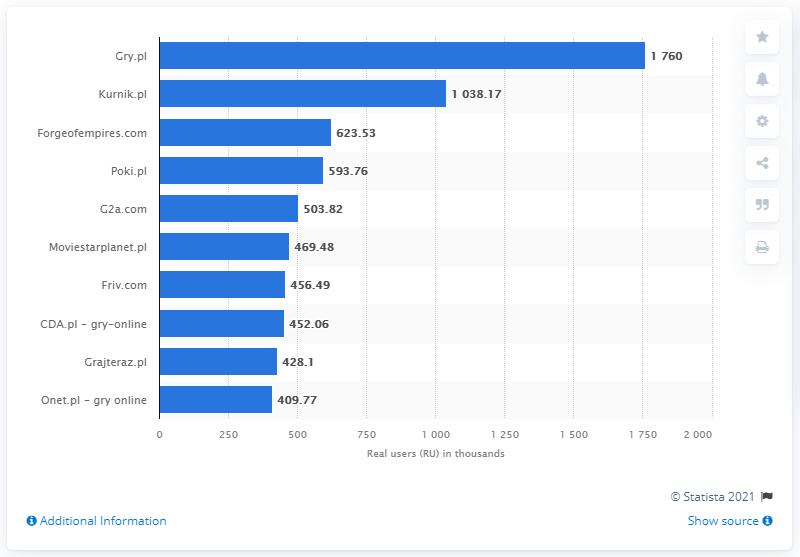What about the popularity of the other sites on this list? What can we infer about their audience? The other sites listed, such as Kurnik.pl and Forgeofempires.com, also show substantial user bases, indicating they have their dedicated players. These platforms might have different game offerings, target demographics, or player communities. For instance, Forgeofempires.com is likely popular among fans of strategy games, while Kurnik.pl could be attracting players that favor classic board and card games. 